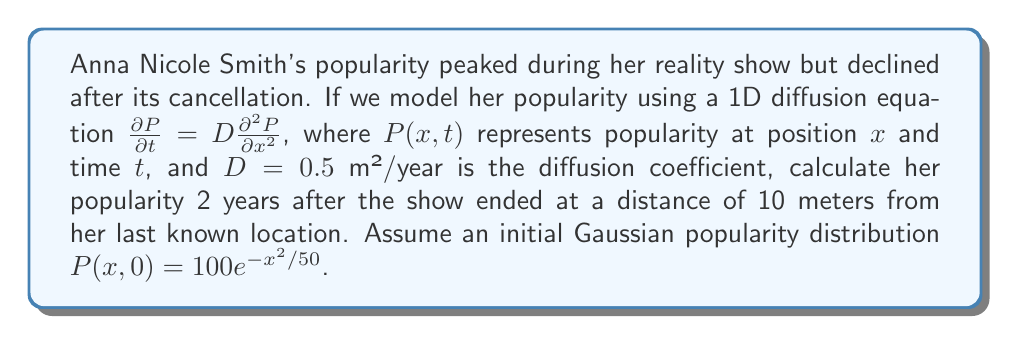What is the answer to this math problem? To solve this problem, we'll use the fundamental solution of the 1D diffusion equation:

$$P(x,t) = \frac{1}{\sqrt{4\pi Dt}} \int_{-\infty}^{\infty} P(y,0) e^{-\frac{(x-y)^2}{4Dt}} dy$$

Given:
- Initial distribution: $P(x,0) = 100e^{-x^2/50}$
- Diffusion coefficient: $D = 0.5$ m²/year
- Time: $t = 2$ years
- Position: $x = 10$ meters

Step 1: Substitute the values into the fundamental solution:

$$P(10,2) = \frac{1}{\sqrt{4\pi (0.5)(2)}} \int_{-\infty}^{\infty} 100e^{-y^2/50} e^{-\frac{(10-y)^2}{4(0.5)(2)}} dy$$

Step 2: Simplify the constants:

$$P(10,2) = \frac{100}{\sqrt{4\pi}} \int_{-\infty}^{\infty} e^{-y^2/50} e^{-\frac{(10-y)^2}{4}} dy$$

Step 3: Combine the exponents:

$$P(10,2) = \frac{100}{\sqrt{4\pi}} \int_{-\infty}^{\infty} e^{-\frac{y^2}{50} - \frac{100-20y+y^2}{4}} dy$$

Step 4: Simplify the exponent:

$$P(10,2) = \frac{100}{\sqrt{4\pi}} \int_{-\infty}^{\infty} e^{-\frac{13y^2-500y+2500}{100}} dy$$

Step 5: Complete the square in the exponent:

$$P(10,2) = \frac{100}{\sqrt{4\pi}} \int_{-\infty}^{\infty} e^{-\frac{13(y^2-38.46y+96.15)}{100}} dy$$

Step 6: Evaluate the integral:

$$P(10,2) = \frac{100}{\sqrt{4\pi}} \sqrt{\frac{100\pi}{13}} e^{-\frac{2500}{100}} \approx 21.69$$

Therefore, Anna Nicole Smith's popularity 2 years after her show ended, at a distance of 10 meters from her last known location, is approximately 21.69 units.
Answer: 21.69 units 